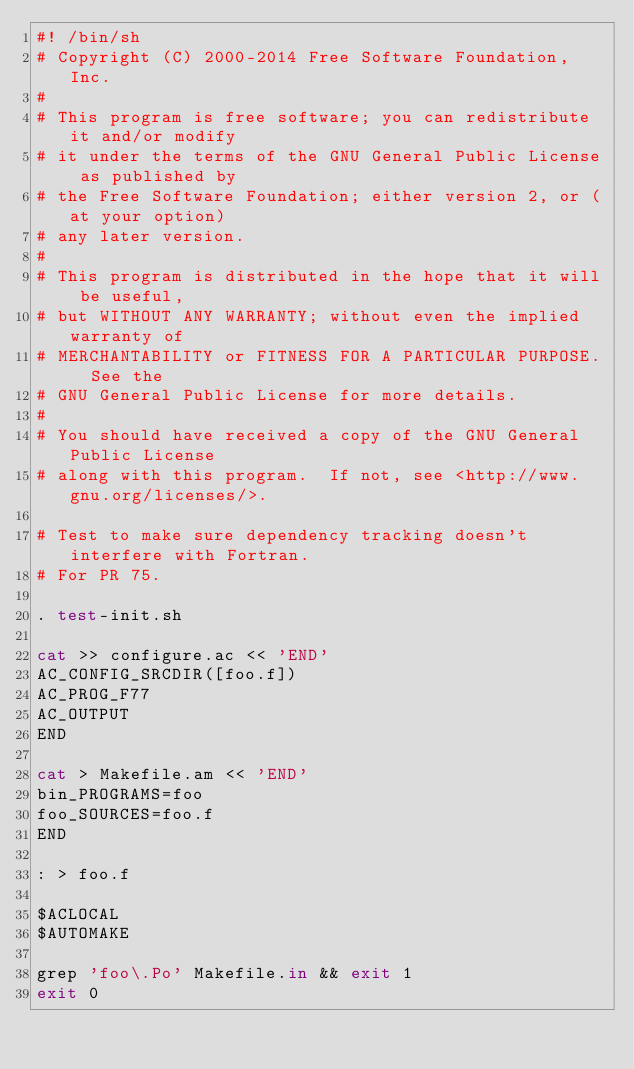<code> <loc_0><loc_0><loc_500><loc_500><_Bash_>#! /bin/sh
# Copyright (C) 2000-2014 Free Software Foundation, Inc.
#
# This program is free software; you can redistribute it and/or modify
# it under the terms of the GNU General Public License as published by
# the Free Software Foundation; either version 2, or (at your option)
# any later version.
#
# This program is distributed in the hope that it will be useful,
# but WITHOUT ANY WARRANTY; without even the implied warranty of
# MERCHANTABILITY or FITNESS FOR A PARTICULAR PURPOSE.  See the
# GNU General Public License for more details.
#
# You should have received a copy of the GNU General Public License
# along with this program.  If not, see <http://www.gnu.org/licenses/>.

# Test to make sure dependency tracking doesn't interfere with Fortran.
# For PR 75.

. test-init.sh

cat >> configure.ac << 'END'
AC_CONFIG_SRCDIR([foo.f])
AC_PROG_F77
AC_OUTPUT
END

cat > Makefile.am << 'END'
bin_PROGRAMS=foo
foo_SOURCES=foo.f
END

: > foo.f

$ACLOCAL
$AUTOMAKE

grep 'foo\.Po' Makefile.in && exit 1
exit 0
</code> 